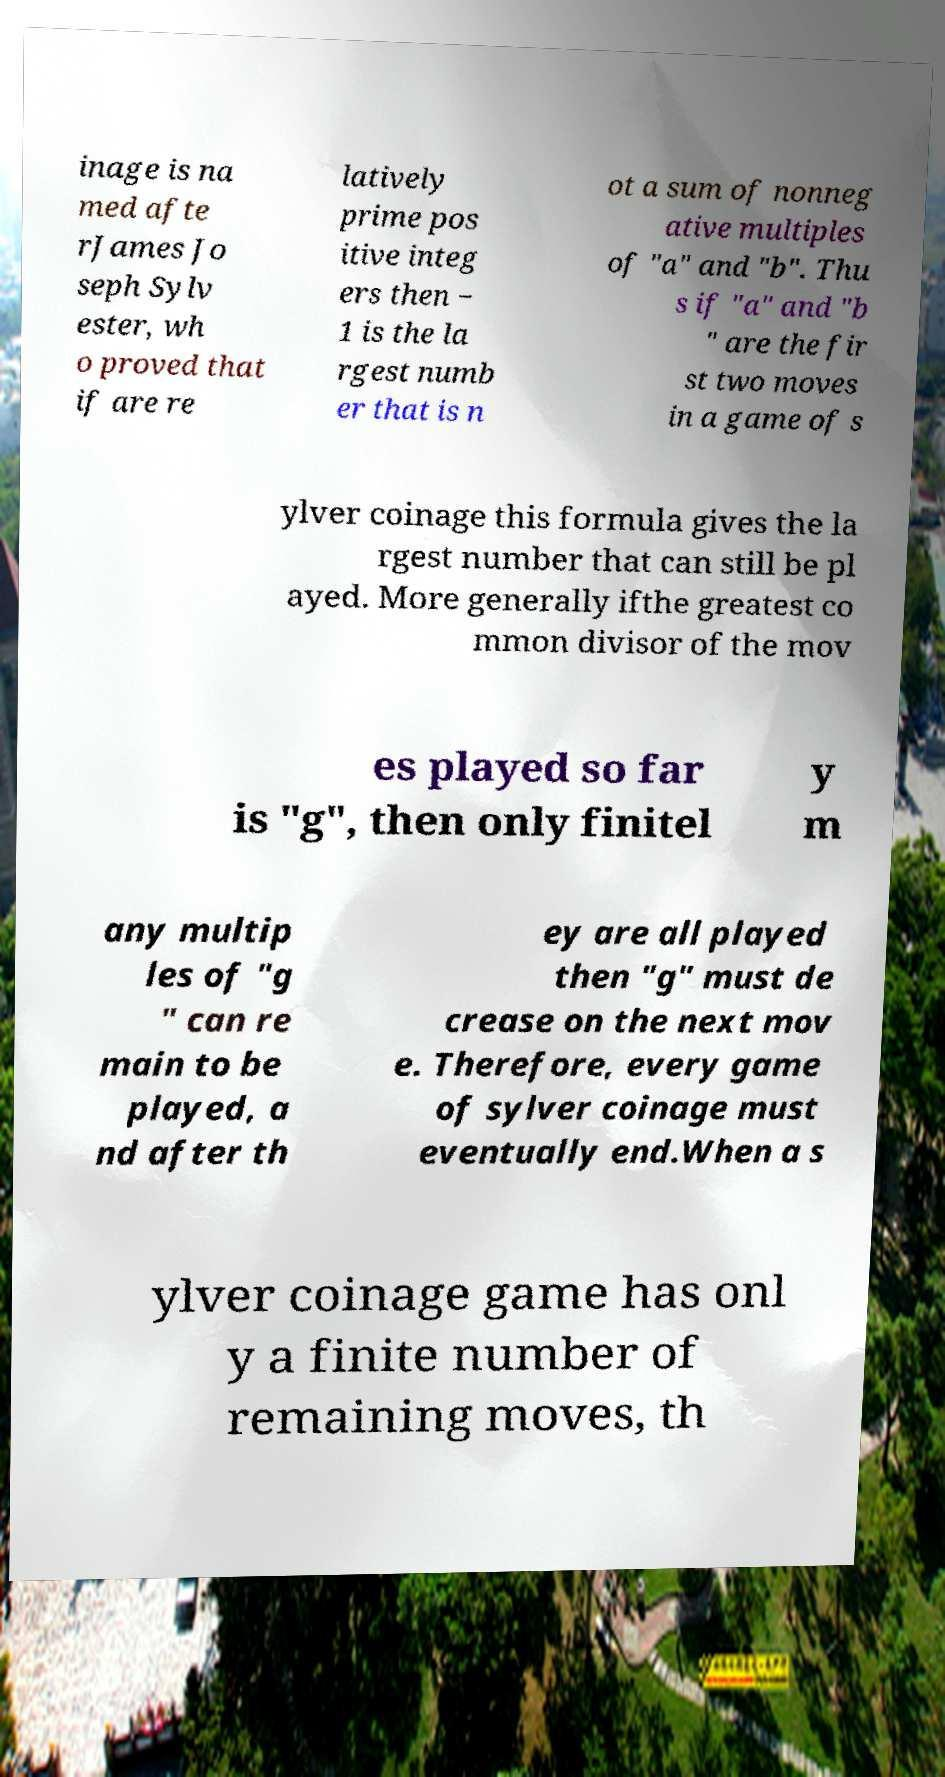Can you accurately transcribe the text from the provided image for me? inage is na med afte rJames Jo seph Sylv ester, wh o proved that if are re latively prime pos itive integ ers then − 1 is the la rgest numb er that is n ot a sum of nonneg ative multiples of "a" and "b". Thu s if "a" and "b " are the fir st two moves in a game of s ylver coinage this formula gives the la rgest number that can still be pl ayed. More generally ifthe greatest co mmon divisor of the mov es played so far is "g", then only finitel y m any multip les of "g " can re main to be played, a nd after th ey are all played then "g" must de crease on the next mov e. Therefore, every game of sylver coinage must eventually end.When a s ylver coinage game has onl y a finite number of remaining moves, th 